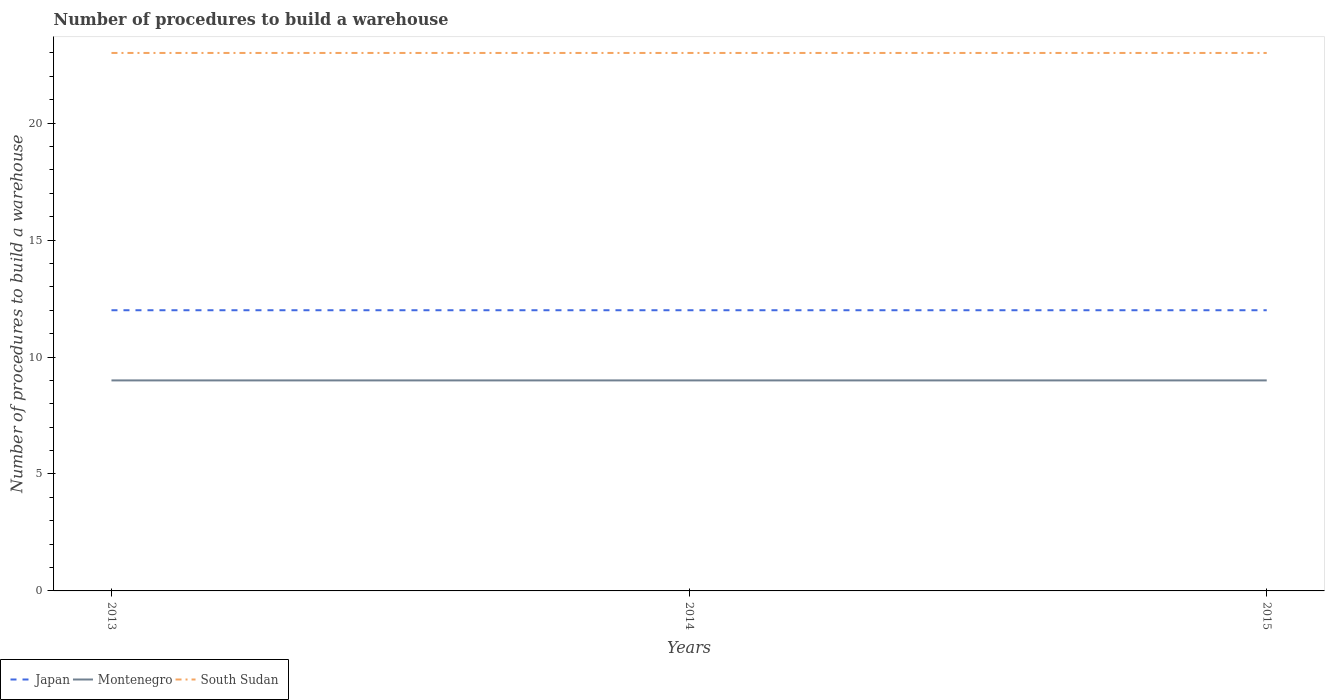Across all years, what is the maximum number of procedures to build a warehouse in in South Sudan?
Provide a succinct answer. 23. In which year was the number of procedures to build a warehouse in in Japan maximum?
Offer a very short reply. 2013. What is the total number of procedures to build a warehouse in in South Sudan in the graph?
Your response must be concise. 0. What is the difference between the highest and the lowest number of procedures to build a warehouse in in Montenegro?
Provide a succinct answer. 0. How many lines are there?
Give a very brief answer. 3. How many years are there in the graph?
Offer a very short reply. 3. Where does the legend appear in the graph?
Provide a short and direct response. Bottom left. What is the title of the graph?
Make the answer very short. Number of procedures to build a warehouse. Does "South Sudan" appear as one of the legend labels in the graph?
Your response must be concise. Yes. What is the label or title of the Y-axis?
Ensure brevity in your answer.  Number of procedures to build a warehouse. What is the Number of procedures to build a warehouse in Japan in 2013?
Provide a succinct answer. 12. What is the Number of procedures to build a warehouse in Montenegro in 2013?
Your answer should be very brief. 9. What is the Number of procedures to build a warehouse of Japan in 2014?
Ensure brevity in your answer.  12. What is the Number of procedures to build a warehouse in Montenegro in 2014?
Offer a very short reply. 9. What is the Number of procedures to build a warehouse in South Sudan in 2014?
Offer a terse response. 23. What is the Number of procedures to build a warehouse in Japan in 2015?
Make the answer very short. 12. What is the Number of procedures to build a warehouse in South Sudan in 2015?
Provide a short and direct response. 23. Across all years, what is the minimum Number of procedures to build a warehouse in Montenegro?
Provide a short and direct response. 9. What is the total Number of procedures to build a warehouse of Japan in the graph?
Your answer should be very brief. 36. What is the total Number of procedures to build a warehouse in Montenegro in the graph?
Offer a very short reply. 27. What is the total Number of procedures to build a warehouse in South Sudan in the graph?
Your answer should be compact. 69. What is the difference between the Number of procedures to build a warehouse of Japan in 2013 and that in 2014?
Your answer should be compact. 0. What is the difference between the Number of procedures to build a warehouse in Montenegro in 2013 and that in 2014?
Provide a short and direct response. 0. What is the difference between the Number of procedures to build a warehouse in South Sudan in 2013 and that in 2014?
Your response must be concise. 0. What is the difference between the Number of procedures to build a warehouse in Japan in 2013 and that in 2015?
Keep it short and to the point. 0. What is the difference between the Number of procedures to build a warehouse in South Sudan in 2013 and that in 2015?
Your response must be concise. 0. What is the difference between the Number of procedures to build a warehouse in South Sudan in 2014 and that in 2015?
Ensure brevity in your answer.  0. What is the difference between the Number of procedures to build a warehouse of Japan in 2013 and the Number of procedures to build a warehouse of Montenegro in 2014?
Your answer should be very brief. 3. What is the difference between the Number of procedures to build a warehouse in Japan in 2013 and the Number of procedures to build a warehouse in South Sudan in 2014?
Your response must be concise. -11. What is the difference between the Number of procedures to build a warehouse in Japan in 2013 and the Number of procedures to build a warehouse in South Sudan in 2015?
Ensure brevity in your answer.  -11. What is the difference between the Number of procedures to build a warehouse of Japan in 2014 and the Number of procedures to build a warehouse of South Sudan in 2015?
Provide a succinct answer. -11. What is the average Number of procedures to build a warehouse in Japan per year?
Provide a succinct answer. 12. In the year 2013, what is the difference between the Number of procedures to build a warehouse of Japan and Number of procedures to build a warehouse of Montenegro?
Keep it short and to the point. 3. In the year 2013, what is the difference between the Number of procedures to build a warehouse in Japan and Number of procedures to build a warehouse in South Sudan?
Provide a succinct answer. -11. In the year 2015, what is the difference between the Number of procedures to build a warehouse of Japan and Number of procedures to build a warehouse of South Sudan?
Your answer should be very brief. -11. What is the ratio of the Number of procedures to build a warehouse in Japan in 2013 to that in 2014?
Give a very brief answer. 1. What is the ratio of the Number of procedures to build a warehouse in Montenegro in 2013 to that in 2014?
Offer a terse response. 1. What is the ratio of the Number of procedures to build a warehouse in South Sudan in 2013 to that in 2014?
Your response must be concise. 1. What is the ratio of the Number of procedures to build a warehouse of South Sudan in 2013 to that in 2015?
Make the answer very short. 1. What is the ratio of the Number of procedures to build a warehouse of Japan in 2014 to that in 2015?
Your answer should be very brief. 1. What is the difference between the highest and the second highest Number of procedures to build a warehouse in Japan?
Your response must be concise. 0. 